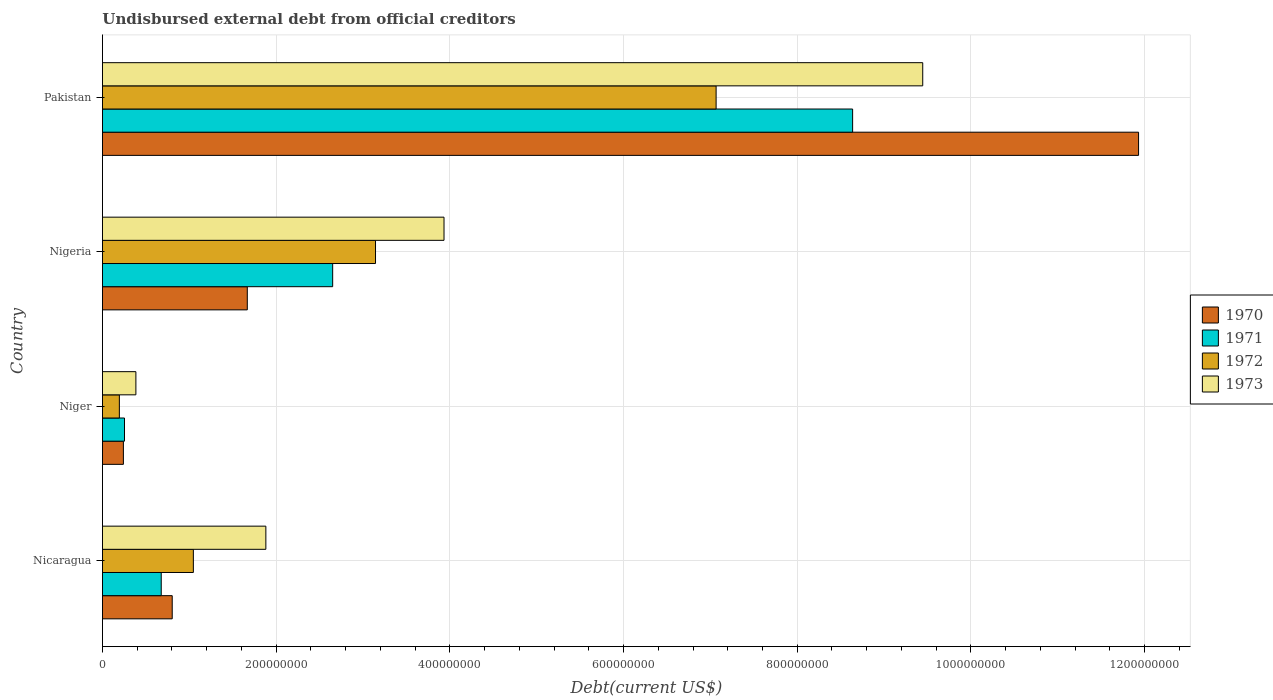How many bars are there on the 1st tick from the top?
Your answer should be very brief. 4. How many bars are there on the 4th tick from the bottom?
Your answer should be compact. 4. What is the label of the 1st group of bars from the top?
Provide a short and direct response. Pakistan. In how many cases, is the number of bars for a given country not equal to the number of legend labels?
Your response must be concise. 0. What is the total debt in 1973 in Nicaragua?
Your response must be concise. 1.88e+08. Across all countries, what is the maximum total debt in 1971?
Your response must be concise. 8.64e+08. Across all countries, what is the minimum total debt in 1970?
Offer a very short reply. 2.41e+07. In which country was the total debt in 1973 maximum?
Your response must be concise. Pakistan. In which country was the total debt in 1971 minimum?
Your answer should be very brief. Niger. What is the total total debt in 1970 in the graph?
Ensure brevity in your answer.  1.46e+09. What is the difference between the total debt in 1971 in Niger and that in Pakistan?
Offer a very short reply. -8.38e+08. What is the difference between the total debt in 1972 in Nigeria and the total debt in 1971 in Pakistan?
Offer a very short reply. -5.49e+08. What is the average total debt in 1970 per country?
Your answer should be compact. 3.66e+08. What is the difference between the total debt in 1973 and total debt in 1971 in Pakistan?
Your answer should be very brief. 8.07e+07. In how many countries, is the total debt in 1970 greater than 1120000000 US$?
Provide a succinct answer. 1. What is the ratio of the total debt in 1973 in Niger to that in Nigeria?
Your answer should be very brief. 0.1. What is the difference between the highest and the second highest total debt in 1971?
Provide a short and direct response. 5.99e+08. What is the difference between the highest and the lowest total debt in 1972?
Offer a very short reply. 6.87e+08. How many bars are there?
Ensure brevity in your answer.  16. Are all the bars in the graph horizontal?
Give a very brief answer. Yes. What is the difference between two consecutive major ticks on the X-axis?
Your response must be concise. 2.00e+08. How are the legend labels stacked?
Your answer should be very brief. Vertical. What is the title of the graph?
Keep it short and to the point. Undisbursed external debt from official creditors. Does "2009" appear as one of the legend labels in the graph?
Your response must be concise. No. What is the label or title of the X-axis?
Your answer should be compact. Debt(current US$). What is the Debt(current US$) of 1970 in Nicaragua?
Your answer should be very brief. 8.03e+07. What is the Debt(current US$) of 1971 in Nicaragua?
Your response must be concise. 6.77e+07. What is the Debt(current US$) of 1972 in Nicaragua?
Offer a very short reply. 1.05e+08. What is the Debt(current US$) in 1973 in Nicaragua?
Your answer should be very brief. 1.88e+08. What is the Debt(current US$) of 1970 in Niger?
Offer a terse response. 2.41e+07. What is the Debt(current US$) of 1971 in Niger?
Offer a terse response. 2.54e+07. What is the Debt(current US$) in 1972 in Niger?
Your answer should be compact. 1.94e+07. What is the Debt(current US$) of 1973 in Niger?
Make the answer very short. 3.85e+07. What is the Debt(current US$) of 1970 in Nigeria?
Your answer should be compact. 1.67e+08. What is the Debt(current US$) in 1971 in Nigeria?
Provide a succinct answer. 2.65e+08. What is the Debt(current US$) in 1972 in Nigeria?
Your answer should be very brief. 3.14e+08. What is the Debt(current US$) of 1973 in Nigeria?
Your answer should be very brief. 3.93e+08. What is the Debt(current US$) of 1970 in Pakistan?
Provide a succinct answer. 1.19e+09. What is the Debt(current US$) in 1971 in Pakistan?
Your answer should be compact. 8.64e+08. What is the Debt(current US$) of 1972 in Pakistan?
Provide a short and direct response. 7.07e+08. What is the Debt(current US$) in 1973 in Pakistan?
Offer a very short reply. 9.44e+08. Across all countries, what is the maximum Debt(current US$) of 1970?
Ensure brevity in your answer.  1.19e+09. Across all countries, what is the maximum Debt(current US$) in 1971?
Your answer should be very brief. 8.64e+08. Across all countries, what is the maximum Debt(current US$) in 1972?
Keep it short and to the point. 7.07e+08. Across all countries, what is the maximum Debt(current US$) in 1973?
Your answer should be very brief. 9.44e+08. Across all countries, what is the minimum Debt(current US$) of 1970?
Make the answer very short. 2.41e+07. Across all countries, what is the minimum Debt(current US$) in 1971?
Your response must be concise. 2.54e+07. Across all countries, what is the minimum Debt(current US$) in 1972?
Your response must be concise. 1.94e+07. Across all countries, what is the minimum Debt(current US$) of 1973?
Your response must be concise. 3.85e+07. What is the total Debt(current US$) in 1970 in the graph?
Ensure brevity in your answer.  1.46e+09. What is the total Debt(current US$) in 1971 in the graph?
Offer a very short reply. 1.22e+09. What is the total Debt(current US$) in 1972 in the graph?
Provide a succinct answer. 1.15e+09. What is the total Debt(current US$) in 1973 in the graph?
Offer a terse response. 1.56e+09. What is the difference between the Debt(current US$) of 1970 in Nicaragua and that in Niger?
Keep it short and to the point. 5.62e+07. What is the difference between the Debt(current US$) of 1971 in Nicaragua and that in Niger?
Provide a succinct answer. 4.23e+07. What is the difference between the Debt(current US$) in 1972 in Nicaragua and that in Niger?
Ensure brevity in your answer.  8.52e+07. What is the difference between the Debt(current US$) of 1973 in Nicaragua and that in Niger?
Offer a very short reply. 1.50e+08. What is the difference between the Debt(current US$) of 1970 in Nicaragua and that in Nigeria?
Provide a succinct answer. -8.65e+07. What is the difference between the Debt(current US$) in 1971 in Nicaragua and that in Nigeria?
Offer a very short reply. -1.97e+08. What is the difference between the Debt(current US$) in 1972 in Nicaragua and that in Nigeria?
Your response must be concise. -2.10e+08. What is the difference between the Debt(current US$) in 1973 in Nicaragua and that in Nigeria?
Your answer should be compact. -2.05e+08. What is the difference between the Debt(current US$) in 1970 in Nicaragua and that in Pakistan?
Provide a short and direct response. -1.11e+09. What is the difference between the Debt(current US$) of 1971 in Nicaragua and that in Pakistan?
Offer a terse response. -7.96e+08. What is the difference between the Debt(current US$) in 1972 in Nicaragua and that in Pakistan?
Your response must be concise. -6.02e+08. What is the difference between the Debt(current US$) in 1973 in Nicaragua and that in Pakistan?
Ensure brevity in your answer.  -7.56e+08. What is the difference between the Debt(current US$) in 1970 in Niger and that in Nigeria?
Keep it short and to the point. -1.43e+08. What is the difference between the Debt(current US$) in 1971 in Niger and that in Nigeria?
Give a very brief answer. -2.40e+08. What is the difference between the Debt(current US$) in 1972 in Niger and that in Nigeria?
Your response must be concise. -2.95e+08. What is the difference between the Debt(current US$) of 1973 in Niger and that in Nigeria?
Offer a terse response. -3.55e+08. What is the difference between the Debt(current US$) of 1970 in Niger and that in Pakistan?
Your answer should be very brief. -1.17e+09. What is the difference between the Debt(current US$) in 1971 in Niger and that in Pakistan?
Make the answer very short. -8.38e+08. What is the difference between the Debt(current US$) in 1972 in Niger and that in Pakistan?
Offer a very short reply. -6.87e+08. What is the difference between the Debt(current US$) of 1973 in Niger and that in Pakistan?
Offer a very short reply. -9.06e+08. What is the difference between the Debt(current US$) in 1970 in Nigeria and that in Pakistan?
Your answer should be compact. -1.03e+09. What is the difference between the Debt(current US$) of 1971 in Nigeria and that in Pakistan?
Your response must be concise. -5.99e+08. What is the difference between the Debt(current US$) of 1972 in Nigeria and that in Pakistan?
Offer a very short reply. -3.92e+08. What is the difference between the Debt(current US$) of 1973 in Nigeria and that in Pakistan?
Ensure brevity in your answer.  -5.51e+08. What is the difference between the Debt(current US$) in 1970 in Nicaragua and the Debt(current US$) in 1971 in Niger?
Ensure brevity in your answer.  5.49e+07. What is the difference between the Debt(current US$) in 1970 in Nicaragua and the Debt(current US$) in 1972 in Niger?
Provide a succinct answer. 6.09e+07. What is the difference between the Debt(current US$) of 1970 in Nicaragua and the Debt(current US$) of 1973 in Niger?
Offer a very short reply. 4.18e+07. What is the difference between the Debt(current US$) in 1971 in Nicaragua and the Debt(current US$) in 1972 in Niger?
Your answer should be compact. 4.82e+07. What is the difference between the Debt(current US$) of 1971 in Nicaragua and the Debt(current US$) of 1973 in Niger?
Give a very brief answer. 2.92e+07. What is the difference between the Debt(current US$) in 1972 in Nicaragua and the Debt(current US$) in 1973 in Niger?
Provide a succinct answer. 6.62e+07. What is the difference between the Debt(current US$) of 1970 in Nicaragua and the Debt(current US$) of 1971 in Nigeria?
Make the answer very short. -1.85e+08. What is the difference between the Debt(current US$) in 1970 in Nicaragua and the Debt(current US$) in 1972 in Nigeria?
Offer a terse response. -2.34e+08. What is the difference between the Debt(current US$) of 1970 in Nicaragua and the Debt(current US$) of 1973 in Nigeria?
Offer a terse response. -3.13e+08. What is the difference between the Debt(current US$) in 1971 in Nicaragua and the Debt(current US$) in 1972 in Nigeria?
Provide a short and direct response. -2.47e+08. What is the difference between the Debt(current US$) in 1971 in Nicaragua and the Debt(current US$) in 1973 in Nigeria?
Offer a very short reply. -3.26e+08. What is the difference between the Debt(current US$) in 1972 in Nicaragua and the Debt(current US$) in 1973 in Nigeria?
Your answer should be very brief. -2.89e+08. What is the difference between the Debt(current US$) in 1970 in Nicaragua and the Debt(current US$) in 1971 in Pakistan?
Your answer should be compact. -7.83e+08. What is the difference between the Debt(current US$) of 1970 in Nicaragua and the Debt(current US$) of 1972 in Pakistan?
Make the answer very short. -6.26e+08. What is the difference between the Debt(current US$) of 1970 in Nicaragua and the Debt(current US$) of 1973 in Pakistan?
Make the answer very short. -8.64e+08. What is the difference between the Debt(current US$) of 1971 in Nicaragua and the Debt(current US$) of 1972 in Pakistan?
Make the answer very short. -6.39e+08. What is the difference between the Debt(current US$) of 1971 in Nicaragua and the Debt(current US$) of 1973 in Pakistan?
Make the answer very short. -8.77e+08. What is the difference between the Debt(current US$) of 1972 in Nicaragua and the Debt(current US$) of 1973 in Pakistan?
Make the answer very short. -8.40e+08. What is the difference between the Debt(current US$) in 1970 in Niger and the Debt(current US$) in 1971 in Nigeria?
Ensure brevity in your answer.  -2.41e+08. What is the difference between the Debt(current US$) of 1970 in Niger and the Debt(current US$) of 1972 in Nigeria?
Offer a terse response. -2.90e+08. What is the difference between the Debt(current US$) in 1970 in Niger and the Debt(current US$) in 1973 in Nigeria?
Offer a very short reply. -3.69e+08. What is the difference between the Debt(current US$) of 1971 in Niger and the Debt(current US$) of 1972 in Nigeria?
Give a very brief answer. -2.89e+08. What is the difference between the Debt(current US$) in 1971 in Niger and the Debt(current US$) in 1973 in Nigeria?
Offer a terse response. -3.68e+08. What is the difference between the Debt(current US$) in 1972 in Niger and the Debt(current US$) in 1973 in Nigeria?
Offer a very short reply. -3.74e+08. What is the difference between the Debt(current US$) in 1970 in Niger and the Debt(current US$) in 1971 in Pakistan?
Provide a short and direct response. -8.40e+08. What is the difference between the Debt(current US$) in 1970 in Niger and the Debt(current US$) in 1972 in Pakistan?
Your response must be concise. -6.82e+08. What is the difference between the Debt(current US$) of 1970 in Niger and the Debt(current US$) of 1973 in Pakistan?
Your answer should be very brief. -9.20e+08. What is the difference between the Debt(current US$) of 1971 in Niger and the Debt(current US$) of 1972 in Pakistan?
Your answer should be very brief. -6.81e+08. What is the difference between the Debt(current US$) of 1971 in Niger and the Debt(current US$) of 1973 in Pakistan?
Give a very brief answer. -9.19e+08. What is the difference between the Debt(current US$) of 1972 in Niger and the Debt(current US$) of 1973 in Pakistan?
Give a very brief answer. -9.25e+08. What is the difference between the Debt(current US$) of 1970 in Nigeria and the Debt(current US$) of 1971 in Pakistan?
Your response must be concise. -6.97e+08. What is the difference between the Debt(current US$) of 1970 in Nigeria and the Debt(current US$) of 1972 in Pakistan?
Offer a terse response. -5.40e+08. What is the difference between the Debt(current US$) of 1970 in Nigeria and the Debt(current US$) of 1973 in Pakistan?
Keep it short and to the point. -7.78e+08. What is the difference between the Debt(current US$) of 1971 in Nigeria and the Debt(current US$) of 1972 in Pakistan?
Offer a terse response. -4.42e+08. What is the difference between the Debt(current US$) of 1971 in Nigeria and the Debt(current US$) of 1973 in Pakistan?
Keep it short and to the point. -6.79e+08. What is the difference between the Debt(current US$) in 1972 in Nigeria and the Debt(current US$) in 1973 in Pakistan?
Your answer should be very brief. -6.30e+08. What is the average Debt(current US$) in 1970 per country?
Your answer should be very brief. 3.66e+08. What is the average Debt(current US$) in 1971 per country?
Make the answer very short. 3.05e+08. What is the average Debt(current US$) of 1972 per country?
Your answer should be compact. 2.86e+08. What is the average Debt(current US$) of 1973 per country?
Provide a short and direct response. 3.91e+08. What is the difference between the Debt(current US$) in 1970 and Debt(current US$) in 1971 in Nicaragua?
Provide a succinct answer. 1.26e+07. What is the difference between the Debt(current US$) of 1970 and Debt(current US$) of 1972 in Nicaragua?
Your answer should be compact. -2.44e+07. What is the difference between the Debt(current US$) of 1970 and Debt(current US$) of 1973 in Nicaragua?
Make the answer very short. -1.08e+08. What is the difference between the Debt(current US$) of 1971 and Debt(current US$) of 1972 in Nicaragua?
Your answer should be compact. -3.70e+07. What is the difference between the Debt(current US$) in 1971 and Debt(current US$) in 1973 in Nicaragua?
Offer a terse response. -1.20e+08. What is the difference between the Debt(current US$) in 1972 and Debt(current US$) in 1973 in Nicaragua?
Your answer should be compact. -8.35e+07. What is the difference between the Debt(current US$) in 1970 and Debt(current US$) in 1971 in Niger?
Offer a terse response. -1.28e+06. What is the difference between the Debt(current US$) in 1970 and Debt(current US$) in 1972 in Niger?
Offer a very short reply. 4.65e+06. What is the difference between the Debt(current US$) in 1970 and Debt(current US$) in 1973 in Niger?
Keep it short and to the point. -1.44e+07. What is the difference between the Debt(current US$) of 1971 and Debt(current US$) of 1972 in Niger?
Offer a terse response. 5.93e+06. What is the difference between the Debt(current US$) of 1971 and Debt(current US$) of 1973 in Niger?
Your answer should be very brief. -1.31e+07. What is the difference between the Debt(current US$) of 1972 and Debt(current US$) of 1973 in Niger?
Your answer should be compact. -1.90e+07. What is the difference between the Debt(current US$) in 1970 and Debt(current US$) in 1971 in Nigeria?
Your response must be concise. -9.83e+07. What is the difference between the Debt(current US$) in 1970 and Debt(current US$) in 1972 in Nigeria?
Offer a terse response. -1.48e+08. What is the difference between the Debt(current US$) of 1970 and Debt(current US$) of 1973 in Nigeria?
Give a very brief answer. -2.27e+08. What is the difference between the Debt(current US$) in 1971 and Debt(current US$) in 1972 in Nigeria?
Provide a short and direct response. -4.93e+07. What is the difference between the Debt(current US$) in 1971 and Debt(current US$) in 1973 in Nigeria?
Provide a short and direct response. -1.28e+08. What is the difference between the Debt(current US$) in 1972 and Debt(current US$) in 1973 in Nigeria?
Your answer should be very brief. -7.89e+07. What is the difference between the Debt(current US$) of 1970 and Debt(current US$) of 1971 in Pakistan?
Offer a terse response. 3.29e+08. What is the difference between the Debt(current US$) in 1970 and Debt(current US$) in 1972 in Pakistan?
Give a very brief answer. 4.86e+08. What is the difference between the Debt(current US$) of 1970 and Debt(current US$) of 1973 in Pakistan?
Ensure brevity in your answer.  2.49e+08. What is the difference between the Debt(current US$) in 1971 and Debt(current US$) in 1972 in Pakistan?
Your response must be concise. 1.57e+08. What is the difference between the Debt(current US$) in 1971 and Debt(current US$) in 1973 in Pakistan?
Make the answer very short. -8.07e+07. What is the difference between the Debt(current US$) in 1972 and Debt(current US$) in 1973 in Pakistan?
Keep it short and to the point. -2.38e+08. What is the ratio of the Debt(current US$) in 1970 in Nicaragua to that in Niger?
Keep it short and to the point. 3.33. What is the ratio of the Debt(current US$) of 1971 in Nicaragua to that in Niger?
Make the answer very short. 2.67. What is the ratio of the Debt(current US$) of 1972 in Nicaragua to that in Niger?
Ensure brevity in your answer.  5.38. What is the ratio of the Debt(current US$) of 1973 in Nicaragua to that in Niger?
Keep it short and to the point. 4.89. What is the ratio of the Debt(current US$) in 1970 in Nicaragua to that in Nigeria?
Your answer should be compact. 0.48. What is the ratio of the Debt(current US$) of 1971 in Nicaragua to that in Nigeria?
Ensure brevity in your answer.  0.26. What is the ratio of the Debt(current US$) of 1972 in Nicaragua to that in Nigeria?
Provide a succinct answer. 0.33. What is the ratio of the Debt(current US$) of 1973 in Nicaragua to that in Nigeria?
Give a very brief answer. 0.48. What is the ratio of the Debt(current US$) of 1970 in Nicaragua to that in Pakistan?
Provide a succinct answer. 0.07. What is the ratio of the Debt(current US$) of 1971 in Nicaragua to that in Pakistan?
Provide a short and direct response. 0.08. What is the ratio of the Debt(current US$) of 1972 in Nicaragua to that in Pakistan?
Keep it short and to the point. 0.15. What is the ratio of the Debt(current US$) of 1973 in Nicaragua to that in Pakistan?
Offer a terse response. 0.2. What is the ratio of the Debt(current US$) of 1970 in Niger to that in Nigeria?
Your response must be concise. 0.14. What is the ratio of the Debt(current US$) of 1971 in Niger to that in Nigeria?
Your answer should be very brief. 0.1. What is the ratio of the Debt(current US$) in 1972 in Niger to that in Nigeria?
Ensure brevity in your answer.  0.06. What is the ratio of the Debt(current US$) in 1973 in Niger to that in Nigeria?
Provide a succinct answer. 0.1. What is the ratio of the Debt(current US$) in 1970 in Niger to that in Pakistan?
Offer a terse response. 0.02. What is the ratio of the Debt(current US$) of 1971 in Niger to that in Pakistan?
Give a very brief answer. 0.03. What is the ratio of the Debt(current US$) in 1972 in Niger to that in Pakistan?
Ensure brevity in your answer.  0.03. What is the ratio of the Debt(current US$) of 1973 in Niger to that in Pakistan?
Your answer should be compact. 0.04. What is the ratio of the Debt(current US$) in 1970 in Nigeria to that in Pakistan?
Your answer should be compact. 0.14. What is the ratio of the Debt(current US$) of 1971 in Nigeria to that in Pakistan?
Give a very brief answer. 0.31. What is the ratio of the Debt(current US$) in 1972 in Nigeria to that in Pakistan?
Offer a very short reply. 0.45. What is the ratio of the Debt(current US$) of 1973 in Nigeria to that in Pakistan?
Give a very brief answer. 0.42. What is the difference between the highest and the second highest Debt(current US$) of 1970?
Your answer should be very brief. 1.03e+09. What is the difference between the highest and the second highest Debt(current US$) of 1971?
Your response must be concise. 5.99e+08. What is the difference between the highest and the second highest Debt(current US$) in 1972?
Offer a very short reply. 3.92e+08. What is the difference between the highest and the second highest Debt(current US$) in 1973?
Provide a succinct answer. 5.51e+08. What is the difference between the highest and the lowest Debt(current US$) of 1970?
Ensure brevity in your answer.  1.17e+09. What is the difference between the highest and the lowest Debt(current US$) of 1971?
Make the answer very short. 8.38e+08. What is the difference between the highest and the lowest Debt(current US$) in 1972?
Keep it short and to the point. 6.87e+08. What is the difference between the highest and the lowest Debt(current US$) of 1973?
Your answer should be compact. 9.06e+08. 